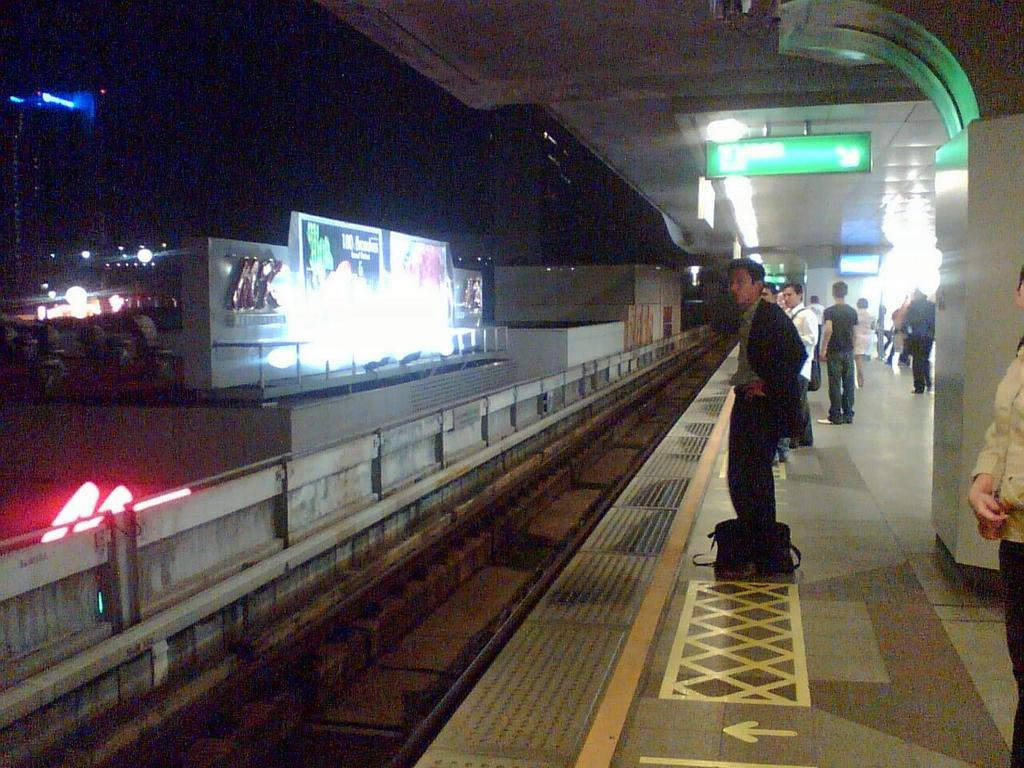What type of structure is located on the right side of the image? There is a railway platform on the right side of the image. What can be seen on the platform? There are people standing on the platform. What is visible in the image besides the platform and people? There is a train track visible in the image. What type of wood is used to build the rock on the platform? There is no rock or wood present on the platform in the image. What game are the people playing while standing on the platform? There is no game being played by the people on the platform in the image. 